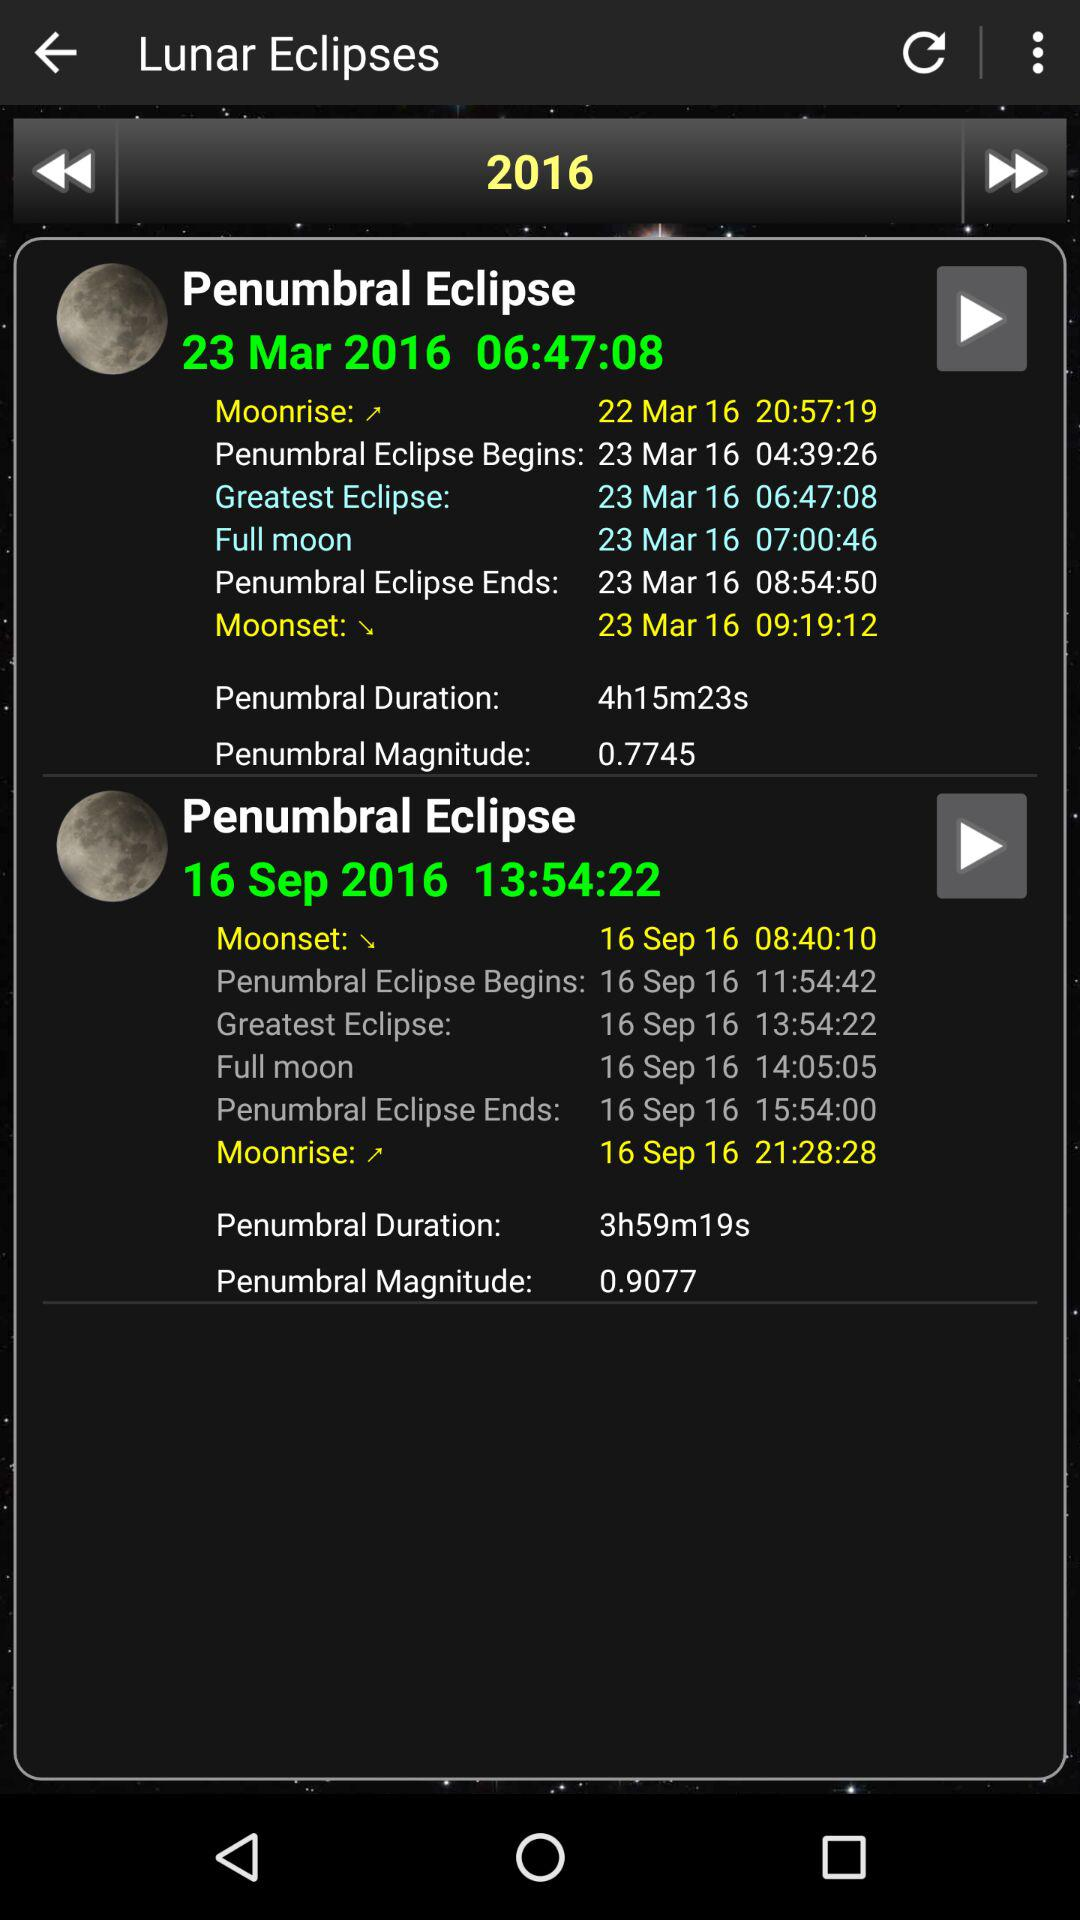What is the moonrise timing on March 22? The time is 20:57:19. 